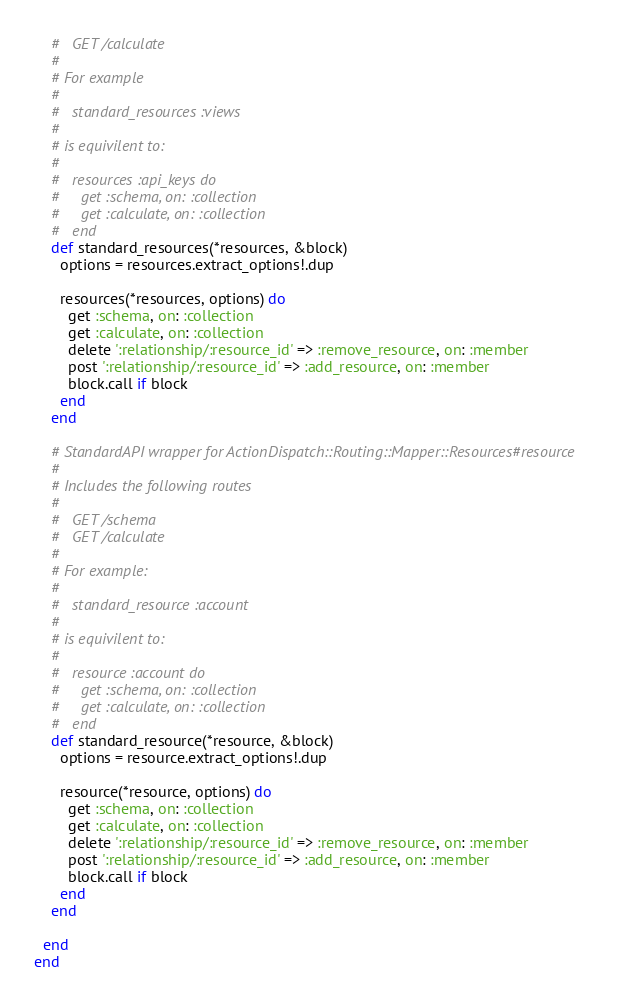<code> <loc_0><loc_0><loc_500><loc_500><_Ruby_>    #   GET /calculate
    #
    # For example
    #
    #   standard_resources :views
    #
    # is equivilent to:
    #
    #   resources :api_keys do
    #     get :schema, on: :collection
    #     get :calculate, on: :collection
    #   end
    def standard_resources(*resources, &block)
      options = resources.extract_options!.dup
      
      resources(*resources, options) do
        get :schema, on: :collection
        get :calculate, on: :collection
        delete ':relationship/:resource_id' => :remove_resource, on: :member
        post ':relationship/:resource_id' => :add_resource, on: :member
        block.call if block
      end
    end

    # StandardAPI wrapper for ActionDispatch::Routing::Mapper::Resources#resource
    #
    # Includes the following routes
    #   
    #   GET /schema
    #   GET /calculate
    #
    # For example:
    #
    #   standard_resource :account
    #
    # is equivilent to:
    #
    #   resource :account do
    #     get :schema, on: :collection
    #     get :calculate, on: :collection
    #   end
    def standard_resource(*resource, &block)
      options = resource.extract_options!.dup
      
      resource(*resource, options) do
        get :schema, on: :collection
        get :calculate, on: :collection
        delete ':relationship/:resource_id' => :remove_resource, on: :member
        post ':relationship/:resource_id' => :add_resource, on: :member
        block.call if block
      end
    end

  end
end
</code> 